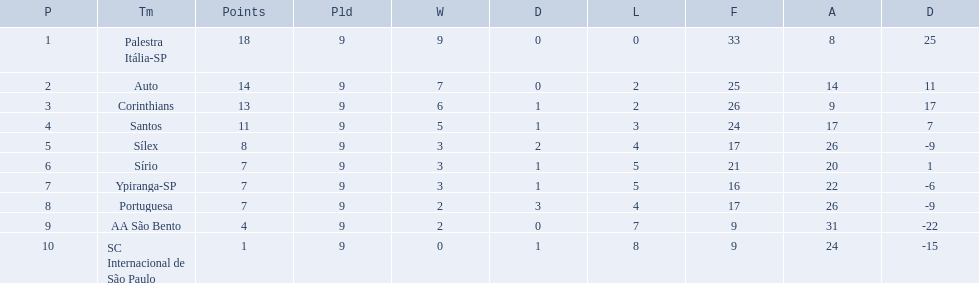What were the top three amounts of games won for 1926 in brazilian football season? 9, 7, 6. What were the top amount of games won for 1926 in brazilian football season? 9. What team won the top amount of games Palestra Itália-SP. 